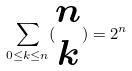Convert formula to latex. <formula><loc_0><loc_0><loc_500><loc_500>\sum _ { 0 \leq k \leq n } ( \begin{matrix} n \\ k \end{matrix} ) = 2 ^ { n }</formula> 